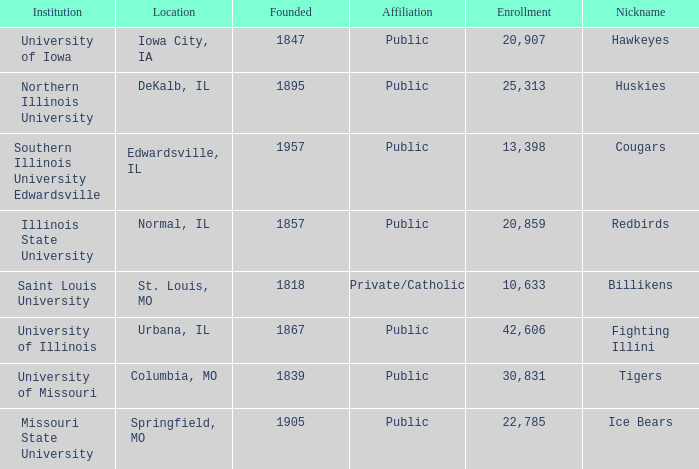I'm looking to parse the entire table for insights. Could you assist me with that? {'header': ['Institution', 'Location', 'Founded', 'Affiliation', 'Enrollment', 'Nickname'], 'rows': [['University of Iowa', 'Iowa City, IA', '1847', 'Public', '20,907', 'Hawkeyes'], ['Northern Illinois University', 'DeKalb, IL', '1895', 'Public', '25,313', 'Huskies'], ['Southern Illinois University Edwardsville', 'Edwardsville, IL', '1957', 'Public', '13,398', 'Cougars'], ['Illinois State University', 'Normal, IL', '1857', 'Public', '20,859', 'Redbirds'], ['Saint Louis University', 'St. Louis, MO', '1818', 'Private/Catholic', '10,633', 'Billikens'], ['University of Illinois', 'Urbana, IL', '1867', 'Public', '42,606', 'Fighting Illini'], ['University of Missouri', 'Columbia, MO', '1839', 'Public', '30,831', 'Tigers'], ['Missouri State University', 'Springfield, MO', '1905', 'Public', '22,785', 'Ice Bears']]} Which institution is private/catholic? Saint Louis University. 